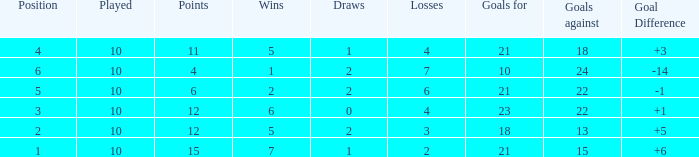Can you tell me the sum of Goals against that has the Goals for larger than 10, and the Position of 3, and the Wins smaller than 6? None. Would you mind parsing the complete table? {'header': ['Position', 'Played', 'Points', 'Wins', 'Draws', 'Losses', 'Goals for', 'Goals against', 'Goal Difference'], 'rows': [['4', '10', '11', '5', '1', '4', '21', '18', '+3'], ['6', '10', '4', '1', '2', '7', '10', '24', '-14'], ['5', '10', '6', '2', '2', '6', '21', '22', '-1'], ['3', '10', '12', '6', '0', '4', '23', '22', '+1'], ['2', '10', '12', '5', '2', '3', '18', '13', '+5'], ['1', '10', '15', '7', '1', '2', '21', '15', '+6']]} 